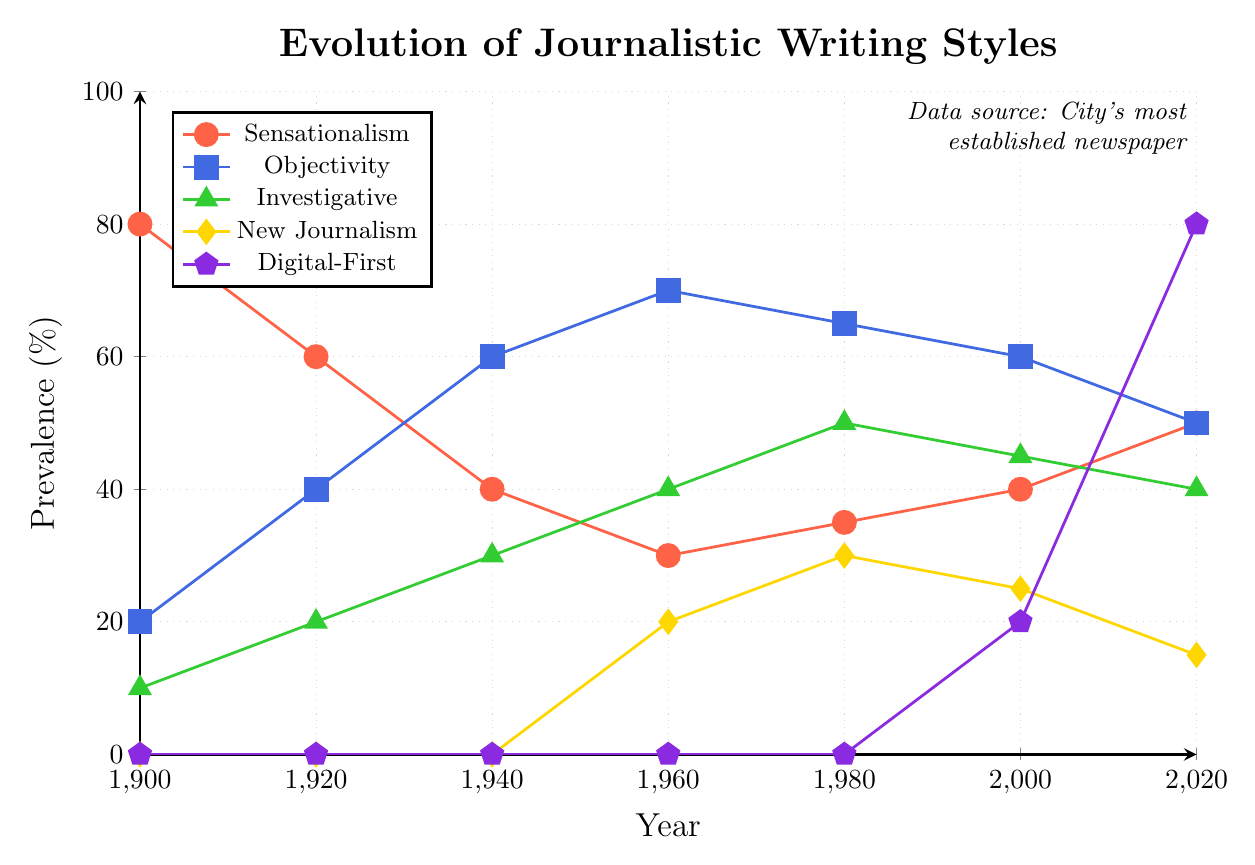Which journalistic writing style was most prevalent in 2020? To determine the most prevalent style in 2020, we need to look at the vertical values in the 2020 column. "Digital-First" has the highest percentage at 80%.
Answer: Digital-First How did the prevalence of Sensationalism change from 1900 to 2020? The line representing Sensationalism starts at 80% in 1900 and ends at 50% in 2020. There is an overall decline from 80% to 50%.
Answer: It decreased Between which two eras did Objectivity reach its peak? We need to look for the highest point in the Objectivity line. This occurs at 70% between 1960 and 1980.
Answer: 1960 and 1980 What was the difference in prevalence between Investigative and New Journalism in 1980? Investigative Journalism had a prevalence of 50%, while New Journalism had 30% in 1980. The difference is \(50 - 30 = 20\).
Answer: 20% Compare the trends of Sensationalism and Objectivity from 1960 to 1980. Sensationalism increased from 30% to 35%, while Objectivity decreased from 70% to 65% during this period.
Answer: Sensationalism increased, Objectivity decreased Which journalistic writing style showed the most significant growth after the year 2000? After 2000, Digital-First increased from 20% to 80% in 2020, showing the most significant growth of 60%.
Answer: Digital-First What is the sum of the prevalence percentages for Sensationalism and Digital-First in 2020? Adding the percentages: Sensationalism (50%) + Digital-First (80%) = 130%.
Answer: 130% In what year did Investigative Journalism overtake Sensationalism in prevalence? Investigative Journalism overtook Sensationalism in 1980, where Investigative (50%) was higher than Sensationalism (35%).
Answer: 1980 Which journalistic writing styles had a non-zero prevalence for the first time in 1960? Both Investigative (40%) and New Journalism (20%) had non-zero prevalence values for the first time in 1960.
Answer: Investigative, New Journalism From 2000 to 2020, which writing style saw a decline in prevalence, and what was the percentage decrease? New Journalism declined from 25% in 2000 to 15% in 2020, a decrease of \(25 - 15 = 10\).
Answer: New Journalism, 10% 